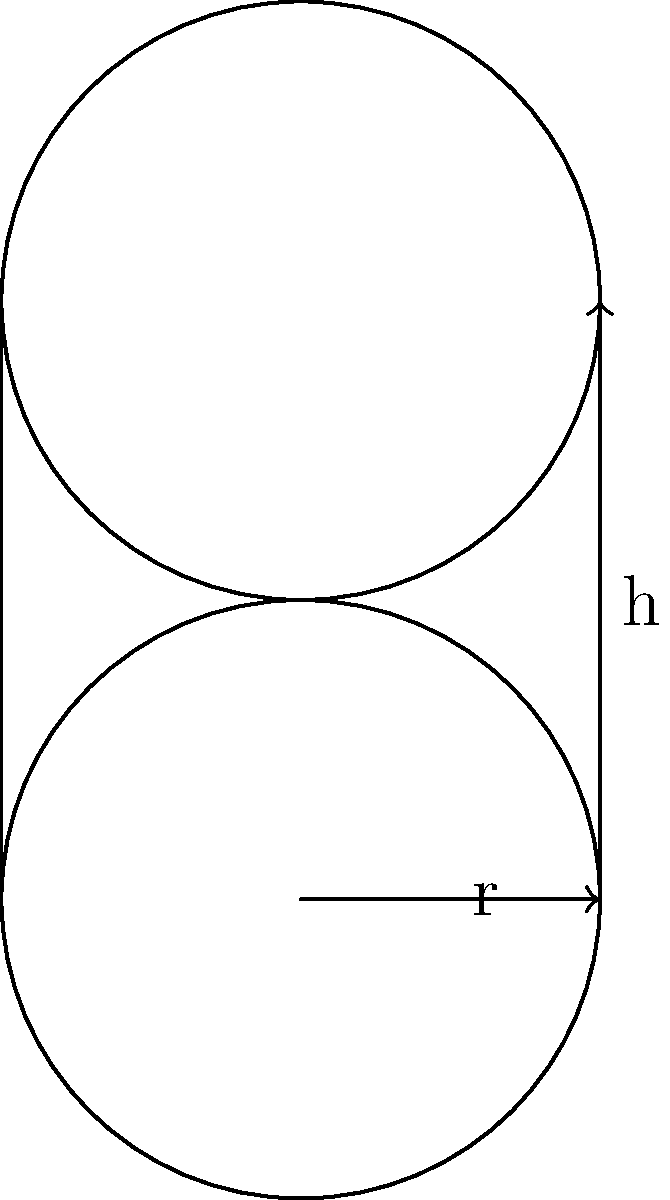A cylindrical data storage device has a radius of 2 cm and a height of 4 cm. If each cubic centimeter can store 100 GB of data, what is the total storage capacity of this device in terabytes (TB)? To solve this problem, we'll follow these steps:

1. Calculate the volume of the cylinder:
   The formula for the volume of a cylinder is $V = \pi r^2 h$
   $V = \pi \cdot 2^2 \cdot 4 = 16\pi$ cm³

2. Calculate the total storage capacity in GB:
   Each cm³ can store 100 GB
   Total capacity in GB = $16\pi \cdot 100 = 1600\pi$ GB

3. Convert GB to TB:
   1 TB = 1000 GB
   Total capacity in TB = $\frac{1600\pi}{1000} = 1.6\pi$ TB

4. Round the result to two decimal places:
   $1.6\pi \approx 5.03$ TB

This approach demonstrates efficiency in calculation and simplicity in problem-solving, which aligns with the persona of a graph database engineer who values simplicity and performance.
Answer: 5.03 TB 